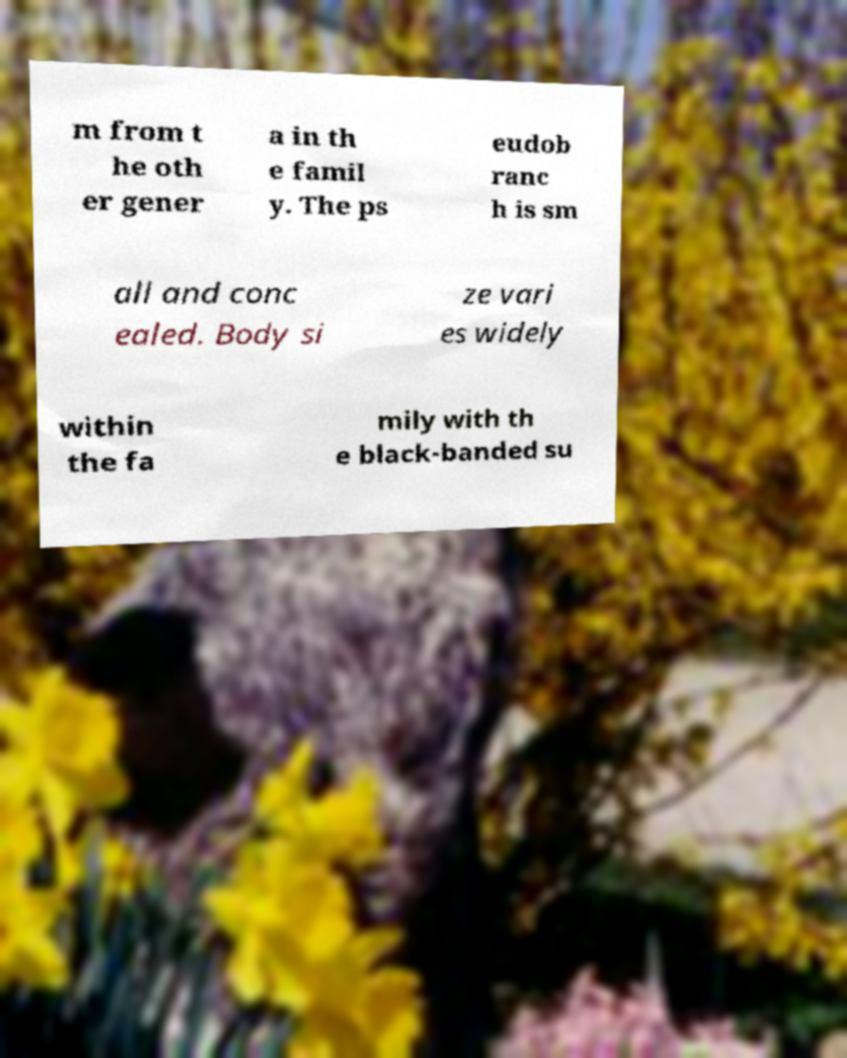For documentation purposes, I need the text within this image transcribed. Could you provide that? m from t he oth er gener a in th e famil y. The ps eudob ranc h is sm all and conc ealed. Body si ze vari es widely within the fa mily with th e black-banded su 